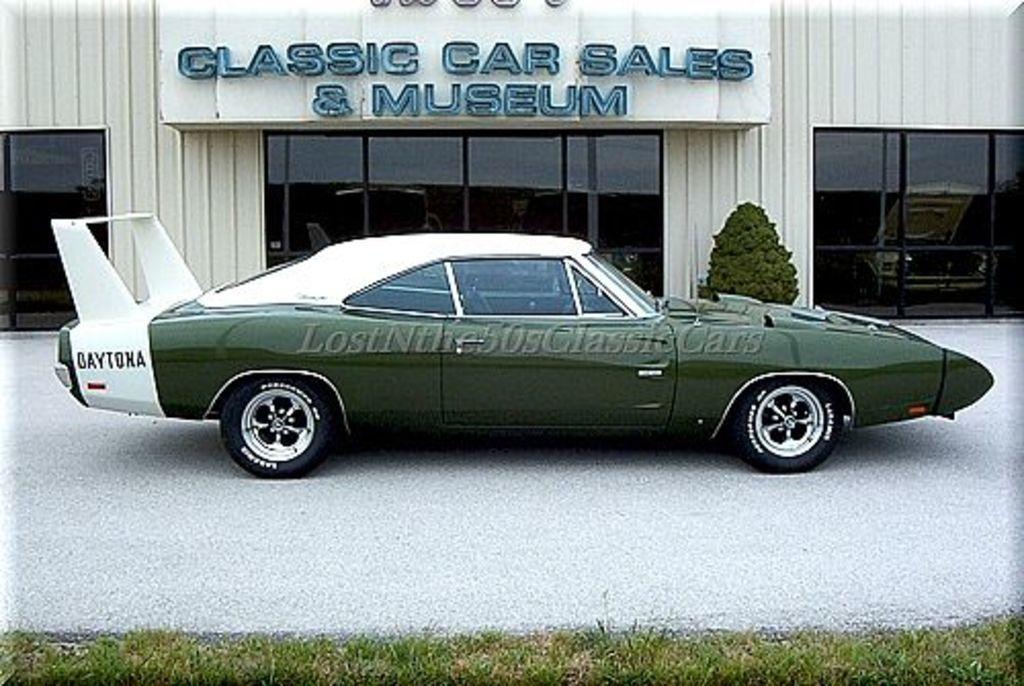Describe this image in one or two sentences. In this picture I can see there is a car parked here and it is in green and white color, there is a building in the backdrop and there is a plant. 